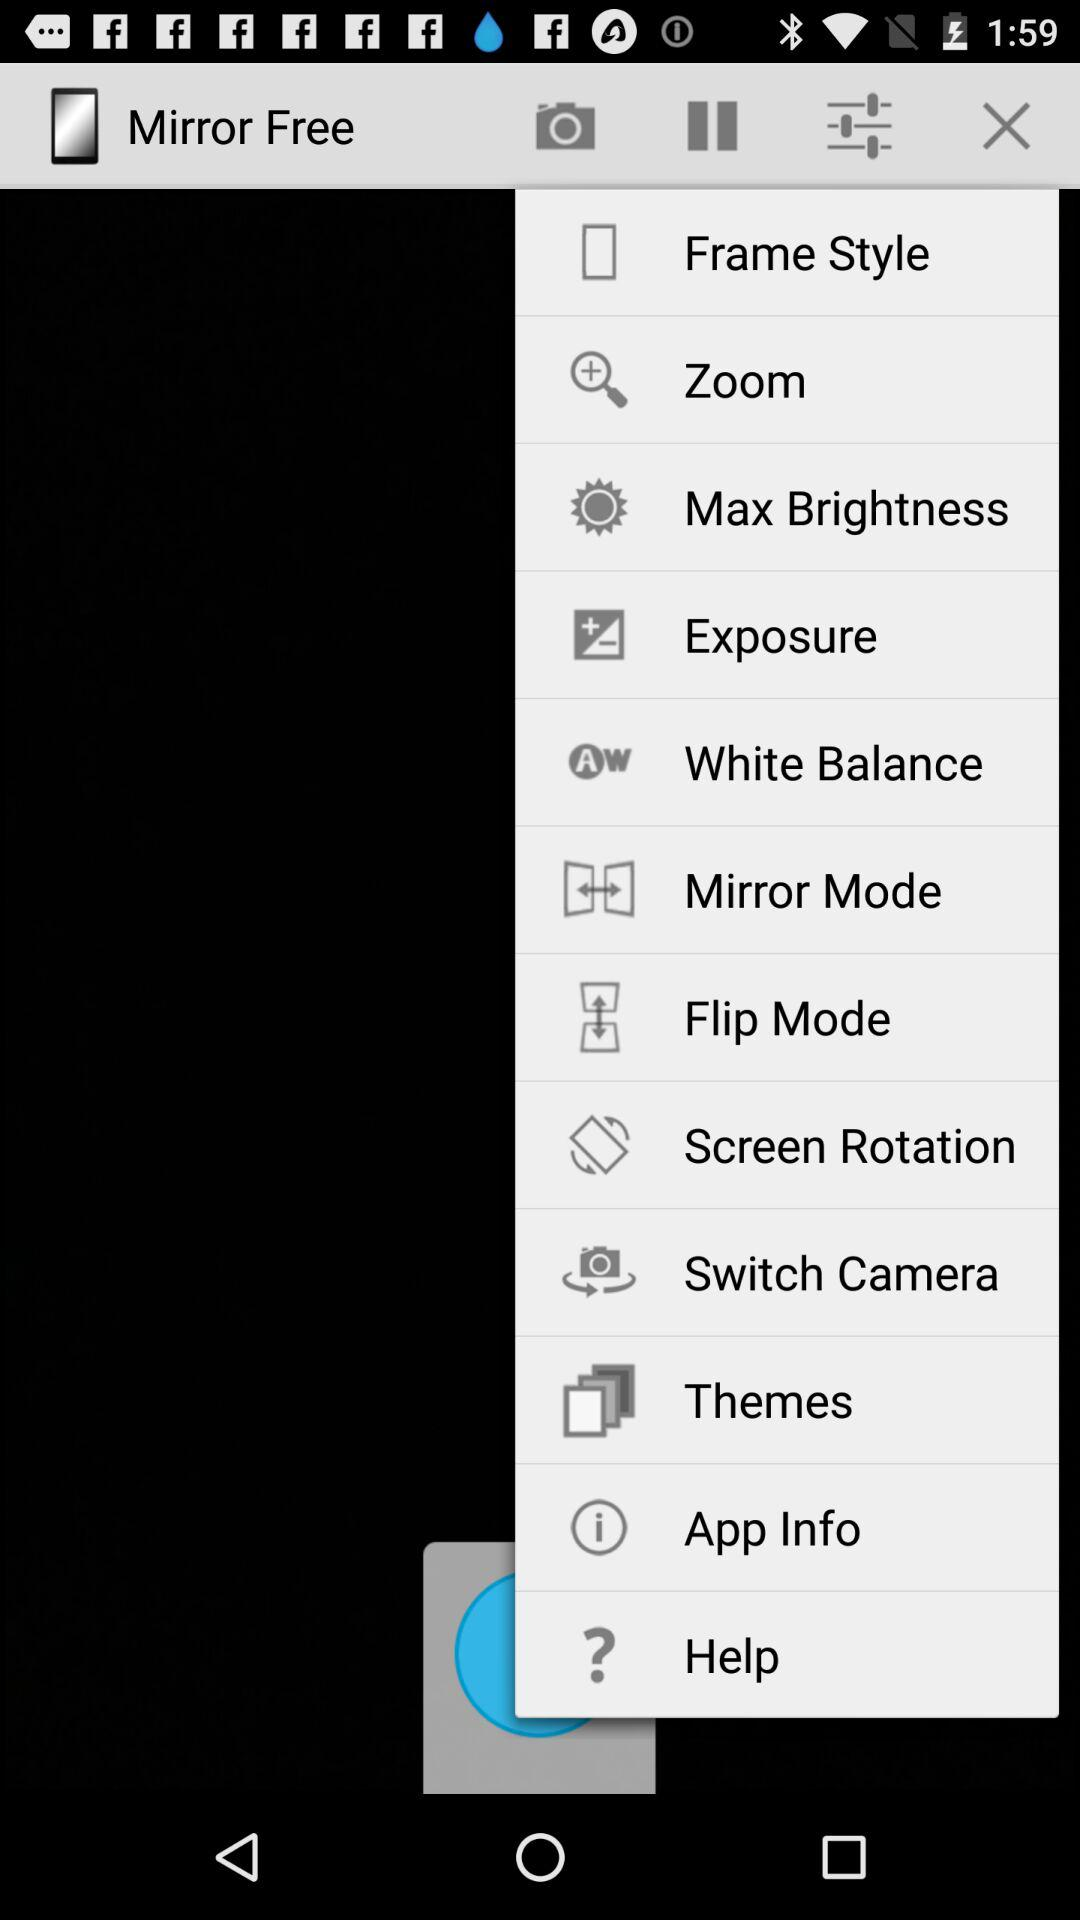How many settings are there in the settings menu?
Answer the question using a single word or phrase. 12 